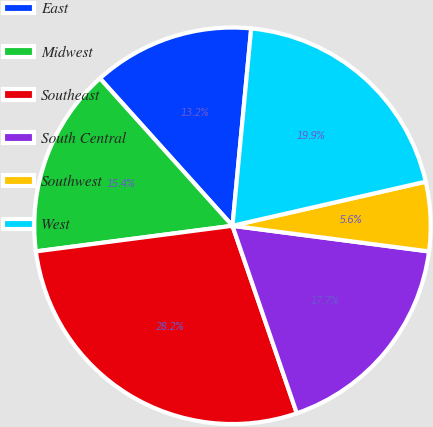Convert chart to OTSL. <chart><loc_0><loc_0><loc_500><loc_500><pie_chart><fcel>East<fcel>Midwest<fcel>Southeast<fcel>South Central<fcel>Southwest<fcel>West<nl><fcel>13.16%<fcel>15.41%<fcel>28.2%<fcel>17.67%<fcel>5.64%<fcel>19.92%<nl></chart> 